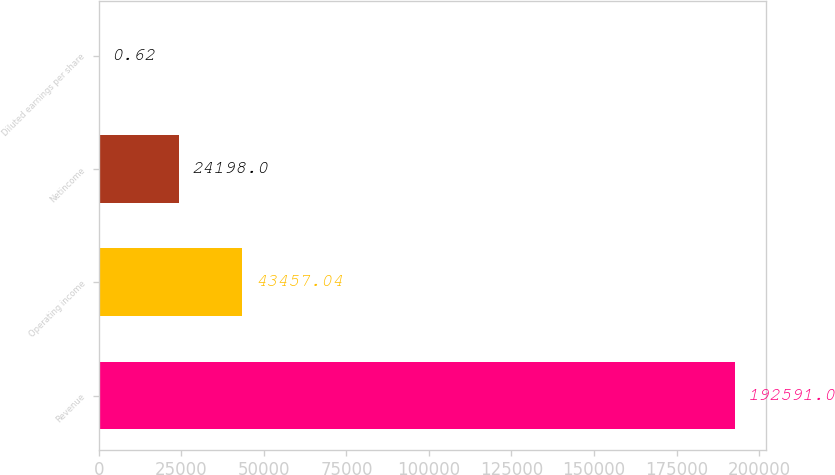<chart> <loc_0><loc_0><loc_500><loc_500><bar_chart><fcel>Revenue<fcel>Operating income<fcel>Netincome<fcel>Diluted earnings per share<nl><fcel>192591<fcel>43457<fcel>24198<fcel>0.62<nl></chart> 